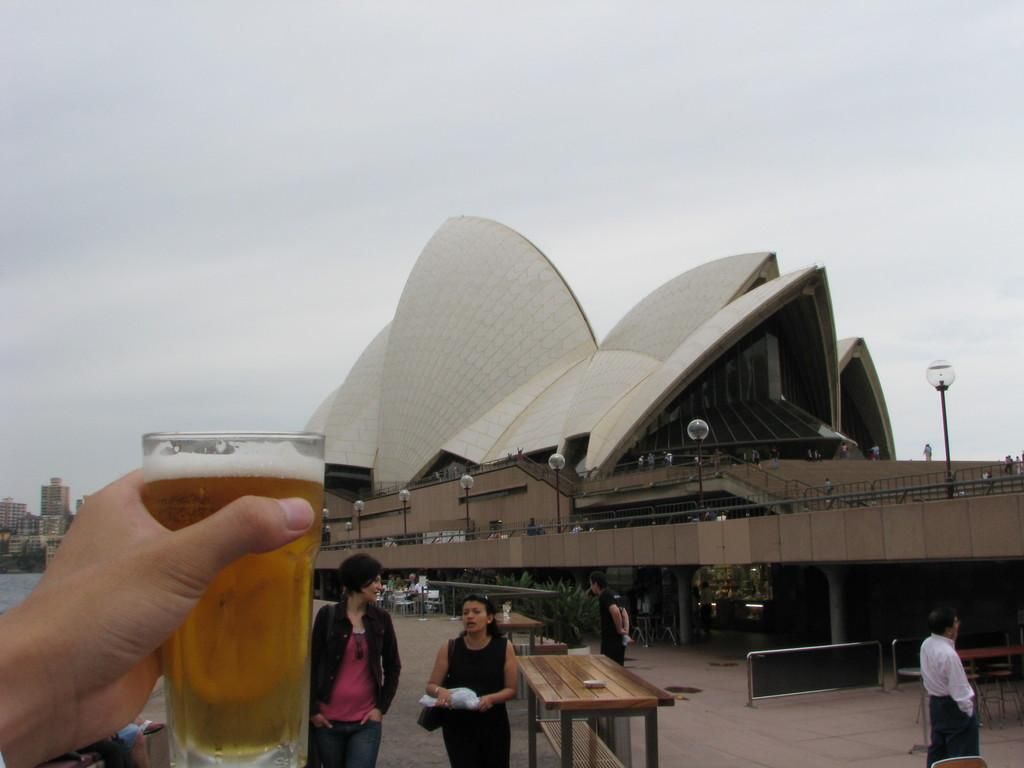What is the person's hand holding in the image? There is a person's hand holding a glass in the image. How many people can be seen in the image? There are people in the image. What type of furniture is present in the image? There are tables in the image. What can be seen in the background of the image? There is a building, light poles, and the sky visible in the background of the image. What type of shirt is the son wearing in the image? There is no son present in the image, and therefore no shirt can be described. 